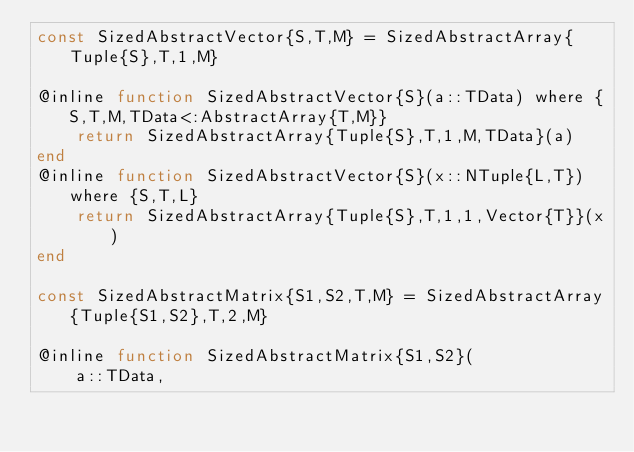Convert code to text. <code><loc_0><loc_0><loc_500><loc_500><_Julia_>const SizedAbstractVector{S,T,M} = SizedAbstractArray{Tuple{S},T,1,M}

@inline function SizedAbstractVector{S}(a::TData) where {S,T,M,TData<:AbstractArray{T,M}}
    return SizedAbstractArray{Tuple{S},T,1,M,TData}(a)
end
@inline function SizedAbstractVector{S}(x::NTuple{L,T}) where {S,T,L}
    return SizedAbstractArray{Tuple{S},T,1,1,Vector{T}}(x)
end

const SizedAbstractMatrix{S1,S2,T,M} = SizedAbstractArray{Tuple{S1,S2},T,2,M}

@inline function SizedAbstractMatrix{S1,S2}(
    a::TData,</code> 